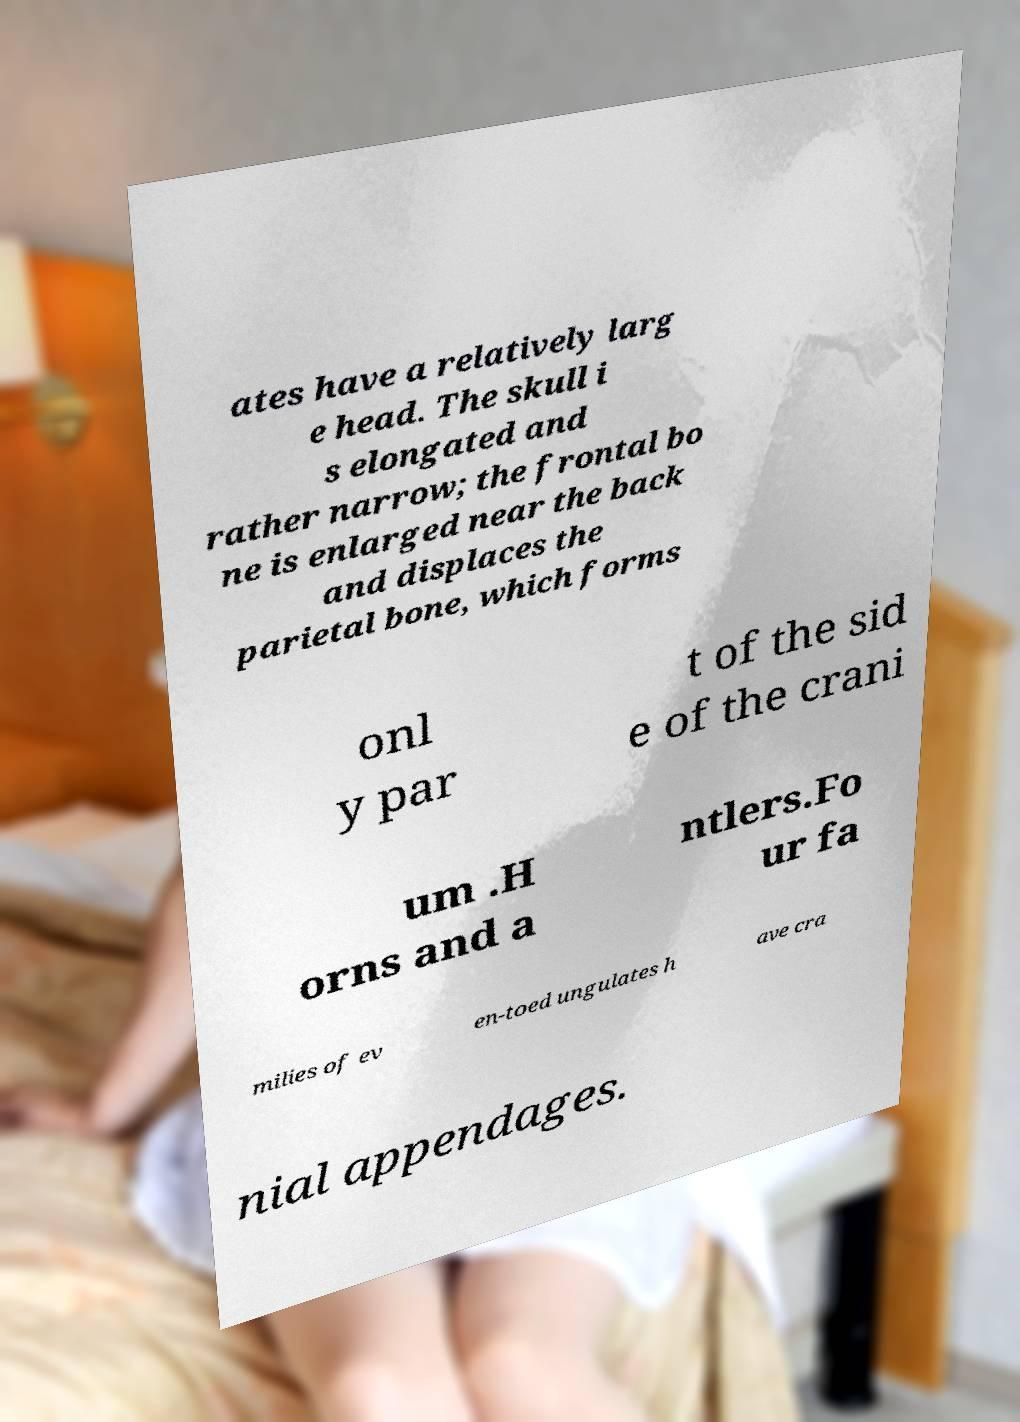Could you extract and type out the text from this image? ates have a relatively larg e head. The skull i s elongated and rather narrow; the frontal bo ne is enlarged near the back and displaces the parietal bone, which forms onl y par t of the sid e of the crani um .H orns and a ntlers.Fo ur fa milies of ev en-toed ungulates h ave cra nial appendages. 